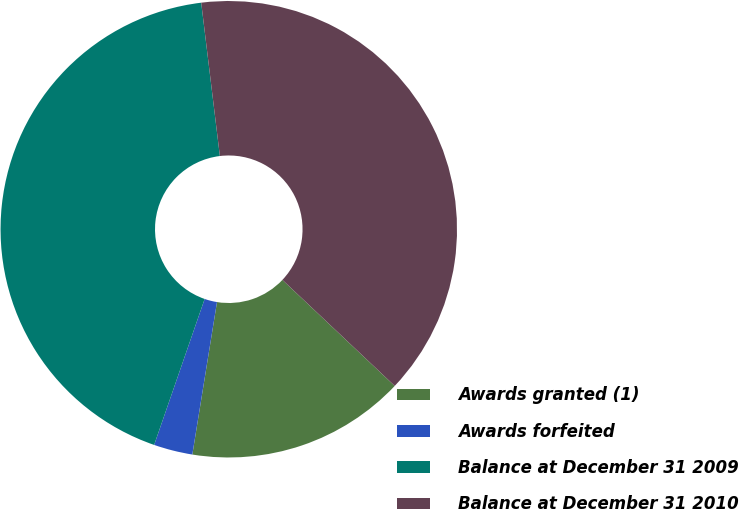Convert chart. <chart><loc_0><loc_0><loc_500><loc_500><pie_chart><fcel>Awards granted (1)<fcel>Awards forfeited<fcel>Balance at December 31 2009<fcel>Balance at December 31 2010<nl><fcel>15.51%<fcel>2.75%<fcel>42.77%<fcel>38.97%<nl></chart> 